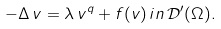Convert formula to latex. <formula><loc_0><loc_0><loc_500><loc_500>- \Delta \, v = \lambda \, v ^ { q } + f ( v ) \, i n \, \mathcal { D } ^ { \prime } ( \Omega ) .</formula> 